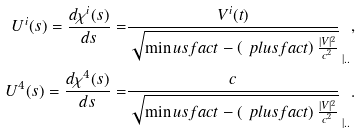<formula> <loc_0><loc_0><loc_500><loc_500>U ^ { i } ( s ) = \frac { d \chi ^ { i } ( s ) } { d s } = & \frac { V ^ { i } ( t ) } { \sqrt { \min u s f a c t - \left ( \ p l u s f a c t \right ) \frac { | V | ^ { 2 } } { c ^ { 2 } } } } _ { \, | . . } , \\ U ^ { 4 } ( s ) = \frac { d \chi ^ { 4 } ( s ) } { d s } = & \frac { c } { \sqrt { \min u s f a c t - \left ( \ p l u s f a c t \right ) \frac { | V | ^ { 2 } } { c ^ { 2 } } } } _ { \, | . . } .</formula> 